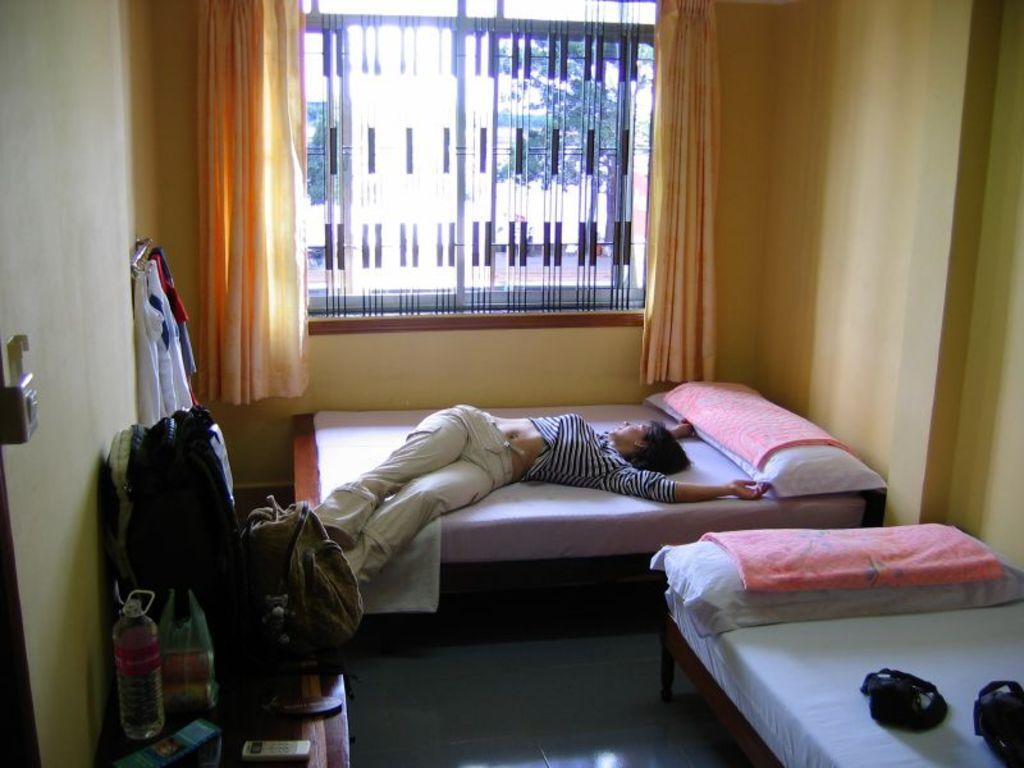What is the main subject of the image? There is a woman sleeping on a bed in the image. Are there any other beds visible in the image? Yes, there is another bed on the right side of the image. What type of object can be seen near the sleeping woman? There is a wooden glass in the image. What type of window treatment is present in the image? There is a curtain in the image. What type of plastic item can be seen in the image? There is no plastic item present in the image. 